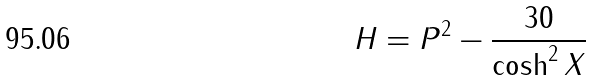<formula> <loc_0><loc_0><loc_500><loc_500>H = P ^ { 2 } - \frac { 3 0 } { \cosh ^ { 2 } X }</formula> 